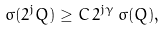Convert formula to latex. <formula><loc_0><loc_0><loc_500><loc_500>\sigma ( 2 ^ { j } Q ) \geq C \, 2 ^ { j \gamma } \, \sigma ( Q ) ,</formula> 